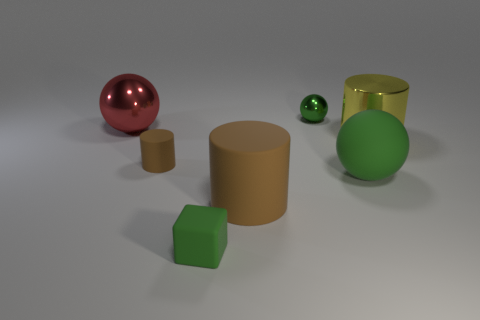There is a yellow shiny thing; is its shape the same as the green rubber thing behind the large brown matte cylinder?
Keep it short and to the point. No. Is the number of brown cylinders that are behind the big green thing less than the number of green rubber objects?
Provide a short and direct response. Yes. There is a large metal sphere; are there any small green rubber objects on the left side of it?
Give a very brief answer. No. Are there any red metallic things that have the same shape as the yellow object?
Your answer should be very brief. No. There is a green matte object that is the same size as the red thing; what shape is it?
Make the answer very short. Sphere. How many objects are either small objects that are behind the big red metallic object or large matte things?
Ensure brevity in your answer.  3. Do the rubber ball and the cube have the same color?
Your response must be concise. Yes. What is the size of the green ball that is in front of the large red thing?
Give a very brief answer. Large. Are there any brown metal balls of the same size as the yellow metal cylinder?
Offer a very short reply. No. Does the cylinder that is to the left of the rubber cube have the same size as the metallic cylinder?
Offer a terse response. No. 